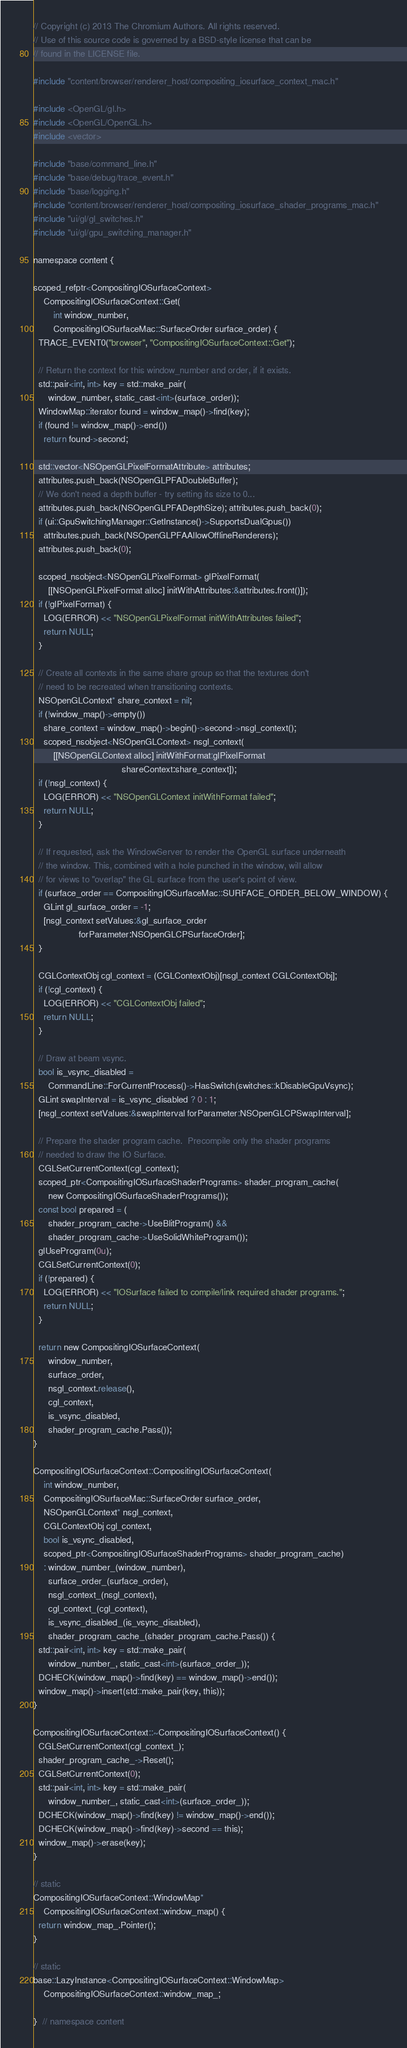Convert code to text. <code><loc_0><loc_0><loc_500><loc_500><_ObjectiveC_>// Copyright (c) 2013 The Chromium Authors. All rights reserved.
// Use of this source code is governed by a BSD-style license that can be
// found in the LICENSE file.

#include "content/browser/renderer_host/compositing_iosurface_context_mac.h"

#include <OpenGL/gl.h>
#include <OpenGL/OpenGL.h>
#include <vector>

#include "base/command_line.h"
#include "base/debug/trace_event.h"
#include "base/logging.h"
#include "content/browser/renderer_host/compositing_iosurface_shader_programs_mac.h"
#include "ui/gl/gl_switches.h"
#include "ui/gl/gpu_switching_manager.h"

namespace content {

scoped_refptr<CompositingIOSurfaceContext>
    CompositingIOSurfaceContext::Get(
        int window_number,
        CompositingIOSurfaceMac::SurfaceOrder surface_order) {
  TRACE_EVENT0("browser", "CompositingIOSurfaceContext::Get");

  // Return the context for this window_number and order, if it exists.
  std::pair<int, int> key = std::make_pair(
      window_number, static_cast<int>(surface_order));
  WindowMap::iterator found = window_map()->find(key);
  if (found != window_map()->end())
    return found->second;

  std::vector<NSOpenGLPixelFormatAttribute> attributes;
  attributes.push_back(NSOpenGLPFADoubleBuffer);
  // We don't need a depth buffer - try setting its size to 0...
  attributes.push_back(NSOpenGLPFADepthSize); attributes.push_back(0);
  if (ui::GpuSwitchingManager::GetInstance()->SupportsDualGpus())
    attributes.push_back(NSOpenGLPFAAllowOfflineRenderers);
  attributes.push_back(0);

  scoped_nsobject<NSOpenGLPixelFormat> glPixelFormat(
      [[NSOpenGLPixelFormat alloc] initWithAttributes:&attributes.front()]);
  if (!glPixelFormat) {
    LOG(ERROR) << "NSOpenGLPixelFormat initWithAttributes failed";
    return NULL;
  }

  // Create all contexts in the same share group so that the textures don't
  // need to be recreated when transitioning contexts.
  NSOpenGLContext* share_context = nil;
  if (!window_map()->empty())
    share_context = window_map()->begin()->second->nsgl_context();
    scoped_nsobject<NSOpenGLContext> nsgl_context(
        [[NSOpenGLContext alloc] initWithFormat:glPixelFormat
                                   shareContext:share_context]);
  if (!nsgl_context) {
    LOG(ERROR) << "NSOpenGLContext initWithFormat failed";
    return NULL;
  }

  // If requested, ask the WindowServer to render the OpenGL surface underneath
  // the window. This, combined with a hole punched in the window, will allow
  // for views to "overlap" the GL surface from the user's point of view.
  if (surface_order == CompositingIOSurfaceMac::SURFACE_ORDER_BELOW_WINDOW) {
    GLint gl_surface_order = -1;
    [nsgl_context setValues:&gl_surface_order
                  forParameter:NSOpenGLCPSurfaceOrder];
  }

  CGLContextObj cgl_context = (CGLContextObj)[nsgl_context CGLContextObj];
  if (!cgl_context) {
    LOG(ERROR) << "CGLContextObj failed";
    return NULL;
  }

  // Draw at beam vsync.
  bool is_vsync_disabled =
      CommandLine::ForCurrentProcess()->HasSwitch(switches::kDisableGpuVsync);
  GLint swapInterval = is_vsync_disabled ? 0 : 1;
  [nsgl_context setValues:&swapInterval forParameter:NSOpenGLCPSwapInterval];

  // Prepare the shader program cache.  Precompile only the shader programs
  // needed to draw the IO Surface.
  CGLSetCurrentContext(cgl_context);
  scoped_ptr<CompositingIOSurfaceShaderPrograms> shader_program_cache(
      new CompositingIOSurfaceShaderPrograms());
  const bool prepared = (
      shader_program_cache->UseBlitProgram() &&
      shader_program_cache->UseSolidWhiteProgram());
  glUseProgram(0u);
  CGLSetCurrentContext(0);
  if (!prepared) {
    LOG(ERROR) << "IOSurface failed to compile/link required shader programs.";
    return NULL;
  }

  return new CompositingIOSurfaceContext(
      window_number,
      surface_order,
      nsgl_context.release(),
      cgl_context,
      is_vsync_disabled,
      shader_program_cache.Pass());
}

CompositingIOSurfaceContext::CompositingIOSurfaceContext(
    int window_number,
    CompositingIOSurfaceMac::SurfaceOrder surface_order,
    NSOpenGLContext* nsgl_context,
    CGLContextObj cgl_context,
    bool is_vsync_disabled,
    scoped_ptr<CompositingIOSurfaceShaderPrograms> shader_program_cache)
    : window_number_(window_number),
      surface_order_(surface_order),
      nsgl_context_(nsgl_context),
      cgl_context_(cgl_context),
      is_vsync_disabled_(is_vsync_disabled),
      shader_program_cache_(shader_program_cache.Pass()) {
  std::pair<int, int> key = std::make_pair(
      window_number_, static_cast<int>(surface_order_));
  DCHECK(window_map()->find(key) == window_map()->end());
  window_map()->insert(std::make_pair(key, this));
}

CompositingIOSurfaceContext::~CompositingIOSurfaceContext() {
  CGLSetCurrentContext(cgl_context_);
  shader_program_cache_->Reset();
  CGLSetCurrentContext(0);
  std::pair<int, int> key = std::make_pair(
      window_number_, static_cast<int>(surface_order_));
  DCHECK(window_map()->find(key) != window_map()->end());
  DCHECK(window_map()->find(key)->second == this);
  window_map()->erase(key);
}

// static
CompositingIOSurfaceContext::WindowMap*
    CompositingIOSurfaceContext::window_map() {
  return window_map_.Pointer();
}

// static
base::LazyInstance<CompositingIOSurfaceContext::WindowMap>
    CompositingIOSurfaceContext::window_map_;

}  // namespace content
</code> 